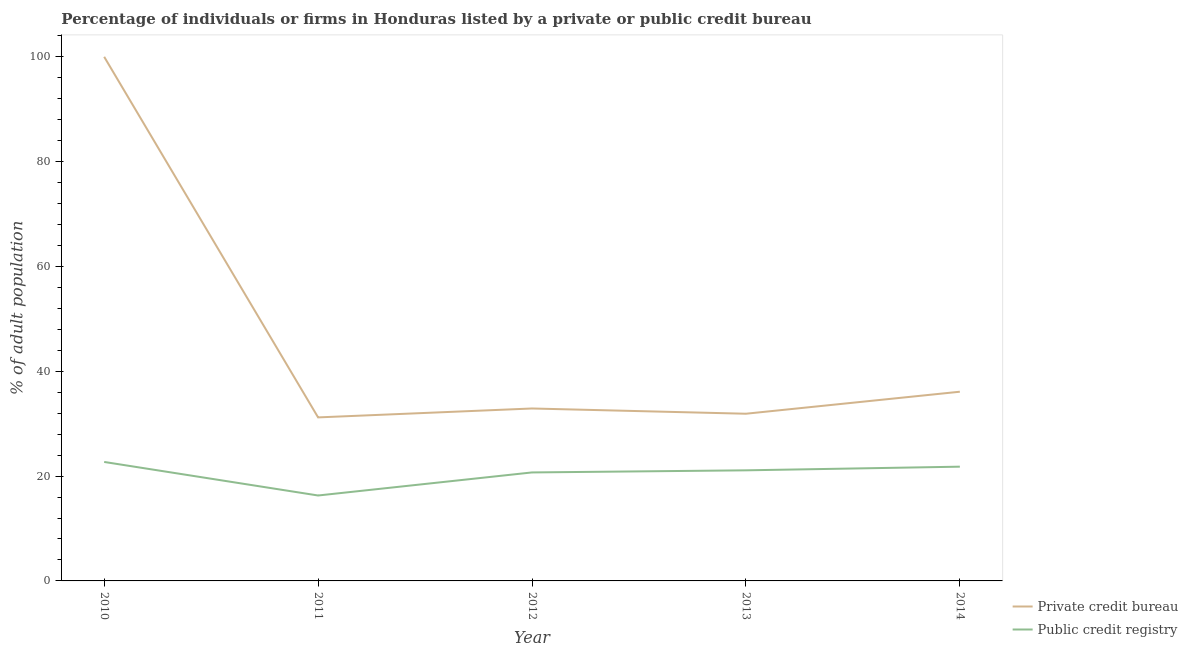What is the percentage of firms listed by public credit bureau in 2012?
Give a very brief answer. 20.7. Across all years, what is the maximum percentage of firms listed by private credit bureau?
Your response must be concise. 100. Across all years, what is the minimum percentage of firms listed by private credit bureau?
Keep it short and to the point. 31.2. What is the total percentage of firms listed by private credit bureau in the graph?
Provide a short and direct response. 232.1. What is the difference between the percentage of firms listed by public credit bureau in 2010 and that in 2014?
Make the answer very short. 0.9. What is the difference between the percentage of firms listed by public credit bureau in 2012 and the percentage of firms listed by private credit bureau in 2010?
Your answer should be very brief. -79.3. What is the average percentage of firms listed by private credit bureau per year?
Your answer should be very brief. 46.42. In the year 2011, what is the difference between the percentage of firms listed by private credit bureau and percentage of firms listed by public credit bureau?
Ensure brevity in your answer.  14.9. What is the ratio of the percentage of firms listed by public credit bureau in 2012 to that in 2013?
Make the answer very short. 0.98. Is the percentage of firms listed by public credit bureau in 2011 less than that in 2013?
Offer a terse response. Yes. What is the difference between the highest and the second highest percentage of firms listed by public credit bureau?
Offer a very short reply. 0.9. What is the difference between the highest and the lowest percentage of firms listed by public credit bureau?
Offer a terse response. 6.4. In how many years, is the percentage of firms listed by public credit bureau greater than the average percentage of firms listed by public credit bureau taken over all years?
Provide a short and direct response. 4. Does the percentage of firms listed by private credit bureau monotonically increase over the years?
Make the answer very short. No. Is the percentage of firms listed by private credit bureau strictly greater than the percentage of firms listed by public credit bureau over the years?
Provide a short and direct response. Yes. Is the percentage of firms listed by private credit bureau strictly less than the percentage of firms listed by public credit bureau over the years?
Offer a very short reply. No. How many lines are there?
Provide a short and direct response. 2. How many years are there in the graph?
Offer a very short reply. 5. What is the difference between two consecutive major ticks on the Y-axis?
Your answer should be very brief. 20. Are the values on the major ticks of Y-axis written in scientific E-notation?
Make the answer very short. No. Does the graph contain any zero values?
Offer a very short reply. No. Where does the legend appear in the graph?
Your answer should be very brief. Bottom right. How many legend labels are there?
Your answer should be very brief. 2. What is the title of the graph?
Your answer should be very brief. Percentage of individuals or firms in Honduras listed by a private or public credit bureau. What is the label or title of the Y-axis?
Give a very brief answer. % of adult population. What is the % of adult population of Private credit bureau in 2010?
Your answer should be compact. 100. What is the % of adult population in Public credit registry in 2010?
Offer a very short reply. 22.7. What is the % of adult population of Private credit bureau in 2011?
Keep it short and to the point. 31.2. What is the % of adult population of Public credit registry in 2011?
Offer a very short reply. 16.3. What is the % of adult population in Private credit bureau in 2012?
Make the answer very short. 32.9. What is the % of adult population in Public credit registry in 2012?
Your response must be concise. 20.7. What is the % of adult population of Private credit bureau in 2013?
Your answer should be compact. 31.9. What is the % of adult population of Public credit registry in 2013?
Make the answer very short. 21.1. What is the % of adult population of Private credit bureau in 2014?
Your answer should be very brief. 36.1. What is the % of adult population in Public credit registry in 2014?
Give a very brief answer. 21.8. Across all years, what is the maximum % of adult population in Public credit registry?
Keep it short and to the point. 22.7. Across all years, what is the minimum % of adult population in Private credit bureau?
Provide a succinct answer. 31.2. Across all years, what is the minimum % of adult population of Public credit registry?
Provide a succinct answer. 16.3. What is the total % of adult population in Private credit bureau in the graph?
Ensure brevity in your answer.  232.1. What is the total % of adult population of Public credit registry in the graph?
Offer a very short reply. 102.6. What is the difference between the % of adult population in Private credit bureau in 2010 and that in 2011?
Make the answer very short. 68.8. What is the difference between the % of adult population of Private credit bureau in 2010 and that in 2012?
Your answer should be compact. 67.1. What is the difference between the % of adult population in Private credit bureau in 2010 and that in 2013?
Provide a succinct answer. 68.1. What is the difference between the % of adult population of Public credit registry in 2010 and that in 2013?
Provide a short and direct response. 1.6. What is the difference between the % of adult population of Private credit bureau in 2010 and that in 2014?
Your response must be concise. 63.9. What is the difference between the % of adult population in Public credit registry in 2010 and that in 2014?
Keep it short and to the point. 0.9. What is the difference between the % of adult population in Private credit bureau in 2011 and that in 2012?
Your answer should be compact. -1.7. What is the difference between the % of adult population of Private credit bureau in 2011 and that in 2013?
Give a very brief answer. -0.7. What is the difference between the % of adult population in Public credit registry in 2011 and that in 2014?
Your response must be concise. -5.5. What is the difference between the % of adult population in Public credit registry in 2012 and that in 2013?
Provide a succinct answer. -0.4. What is the difference between the % of adult population of Public credit registry in 2012 and that in 2014?
Your answer should be compact. -1.1. What is the difference between the % of adult population in Public credit registry in 2013 and that in 2014?
Provide a short and direct response. -0.7. What is the difference between the % of adult population of Private credit bureau in 2010 and the % of adult population of Public credit registry in 2011?
Keep it short and to the point. 83.7. What is the difference between the % of adult population of Private credit bureau in 2010 and the % of adult population of Public credit registry in 2012?
Your response must be concise. 79.3. What is the difference between the % of adult population in Private credit bureau in 2010 and the % of adult population in Public credit registry in 2013?
Keep it short and to the point. 78.9. What is the difference between the % of adult population of Private credit bureau in 2010 and the % of adult population of Public credit registry in 2014?
Make the answer very short. 78.2. What is the difference between the % of adult population of Private credit bureau in 2011 and the % of adult population of Public credit registry in 2013?
Offer a very short reply. 10.1. What is the difference between the % of adult population of Private credit bureau in 2011 and the % of adult population of Public credit registry in 2014?
Offer a terse response. 9.4. What is the difference between the % of adult population in Private credit bureau in 2012 and the % of adult population in Public credit registry in 2013?
Offer a very short reply. 11.8. What is the difference between the % of adult population in Private credit bureau in 2012 and the % of adult population in Public credit registry in 2014?
Provide a succinct answer. 11.1. What is the average % of adult population of Private credit bureau per year?
Give a very brief answer. 46.42. What is the average % of adult population in Public credit registry per year?
Provide a succinct answer. 20.52. In the year 2010, what is the difference between the % of adult population of Private credit bureau and % of adult population of Public credit registry?
Your response must be concise. 77.3. What is the ratio of the % of adult population of Private credit bureau in 2010 to that in 2011?
Provide a succinct answer. 3.21. What is the ratio of the % of adult population of Public credit registry in 2010 to that in 2011?
Your answer should be compact. 1.39. What is the ratio of the % of adult population of Private credit bureau in 2010 to that in 2012?
Give a very brief answer. 3.04. What is the ratio of the % of adult population of Public credit registry in 2010 to that in 2012?
Your response must be concise. 1.1. What is the ratio of the % of adult population of Private credit bureau in 2010 to that in 2013?
Provide a succinct answer. 3.13. What is the ratio of the % of adult population in Public credit registry in 2010 to that in 2013?
Your answer should be compact. 1.08. What is the ratio of the % of adult population in Private credit bureau in 2010 to that in 2014?
Provide a short and direct response. 2.77. What is the ratio of the % of adult population in Public credit registry in 2010 to that in 2014?
Your answer should be very brief. 1.04. What is the ratio of the % of adult population of Private credit bureau in 2011 to that in 2012?
Your answer should be compact. 0.95. What is the ratio of the % of adult population of Public credit registry in 2011 to that in 2012?
Give a very brief answer. 0.79. What is the ratio of the % of adult population in Private credit bureau in 2011 to that in 2013?
Offer a terse response. 0.98. What is the ratio of the % of adult population in Public credit registry in 2011 to that in 2013?
Make the answer very short. 0.77. What is the ratio of the % of adult population of Private credit bureau in 2011 to that in 2014?
Provide a short and direct response. 0.86. What is the ratio of the % of adult population of Public credit registry in 2011 to that in 2014?
Give a very brief answer. 0.75. What is the ratio of the % of adult population in Private credit bureau in 2012 to that in 2013?
Your response must be concise. 1.03. What is the ratio of the % of adult population of Public credit registry in 2012 to that in 2013?
Ensure brevity in your answer.  0.98. What is the ratio of the % of adult population of Private credit bureau in 2012 to that in 2014?
Provide a succinct answer. 0.91. What is the ratio of the % of adult population in Public credit registry in 2012 to that in 2014?
Your response must be concise. 0.95. What is the ratio of the % of adult population in Private credit bureau in 2013 to that in 2014?
Offer a very short reply. 0.88. What is the ratio of the % of adult population in Public credit registry in 2013 to that in 2014?
Your response must be concise. 0.97. What is the difference between the highest and the second highest % of adult population in Private credit bureau?
Give a very brief answer. 63.9. What is the difference between the highest and the second highest % of adult population of Public credit registry?
Your answer should be compact. 0.9. What is the difference between the highest and the lowest % of adult population in Private credit bureau?
Keep it short and to the point. 68.8. 